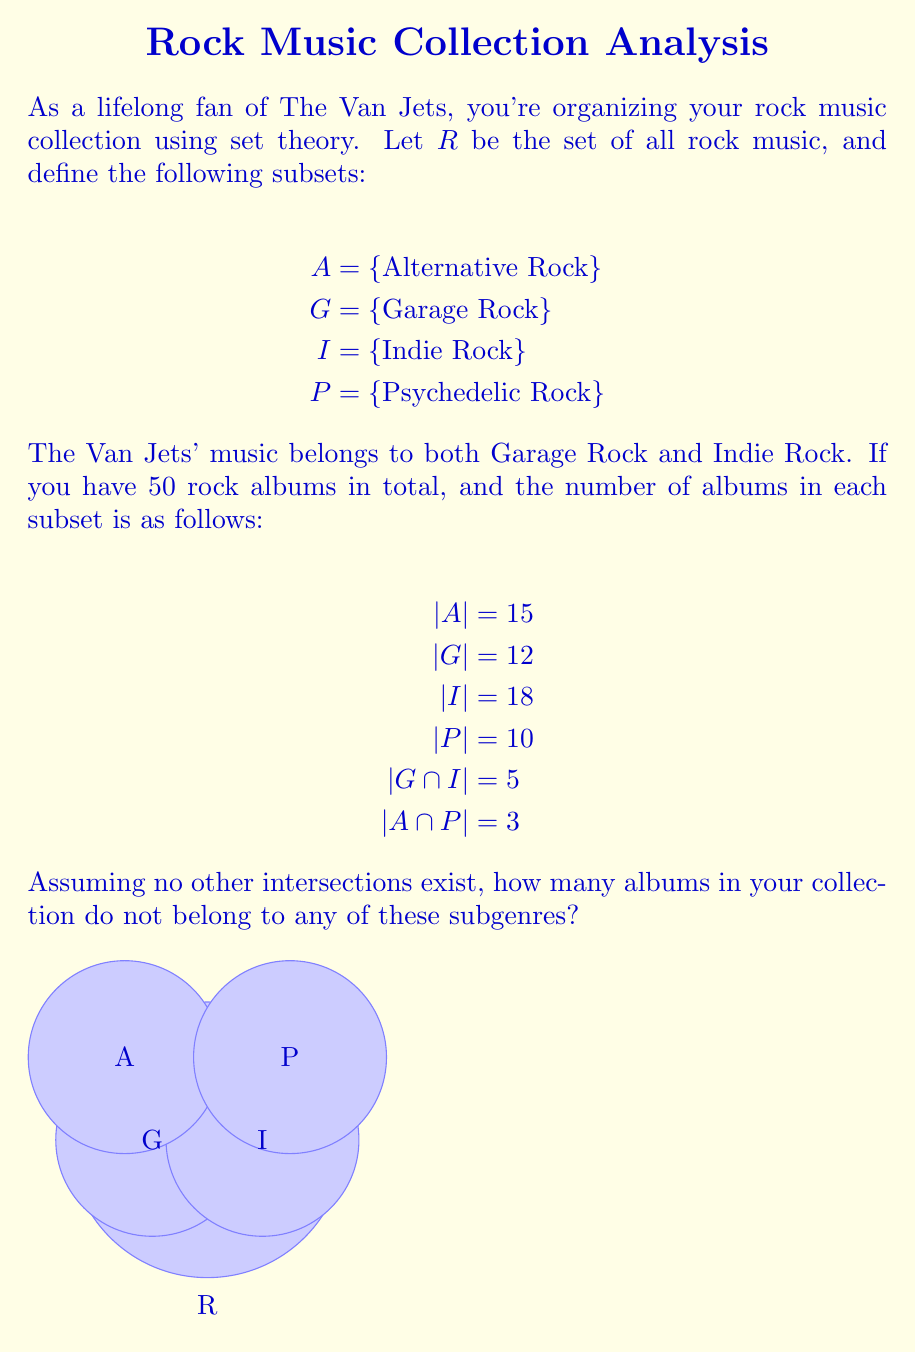Help me with this question. Let's approach this step-by-step using set theory:

1) First, we need to find the total number of albums in the four subgenres. We can use the inclusion-exclusion principle:

   $|A \cup G \cup I \cup P| = |A| + |G| + |I| + |P| - |A \cap P| - |G \cap I|$

2) Substituting the given values:

   $|A \cup G \cup I \cup P| = 15 + 12 + 18 + 10 - 3 - 5 = 47$

3) Now, we know that the total number of albums in R is 50, and the number of albums in the union of the four subgenres is 47.

4) To find the number of albums that don't belong to any of these subgenres, we need to subtract the number of albums in the union from the total number of albums:

   $|R| - |A \cup G \cup I \cup P| = 50 - 47 = 3$

Therefore, 3 albums in the collection do not belong to any of these subgenres.
Answer: 3 albums 